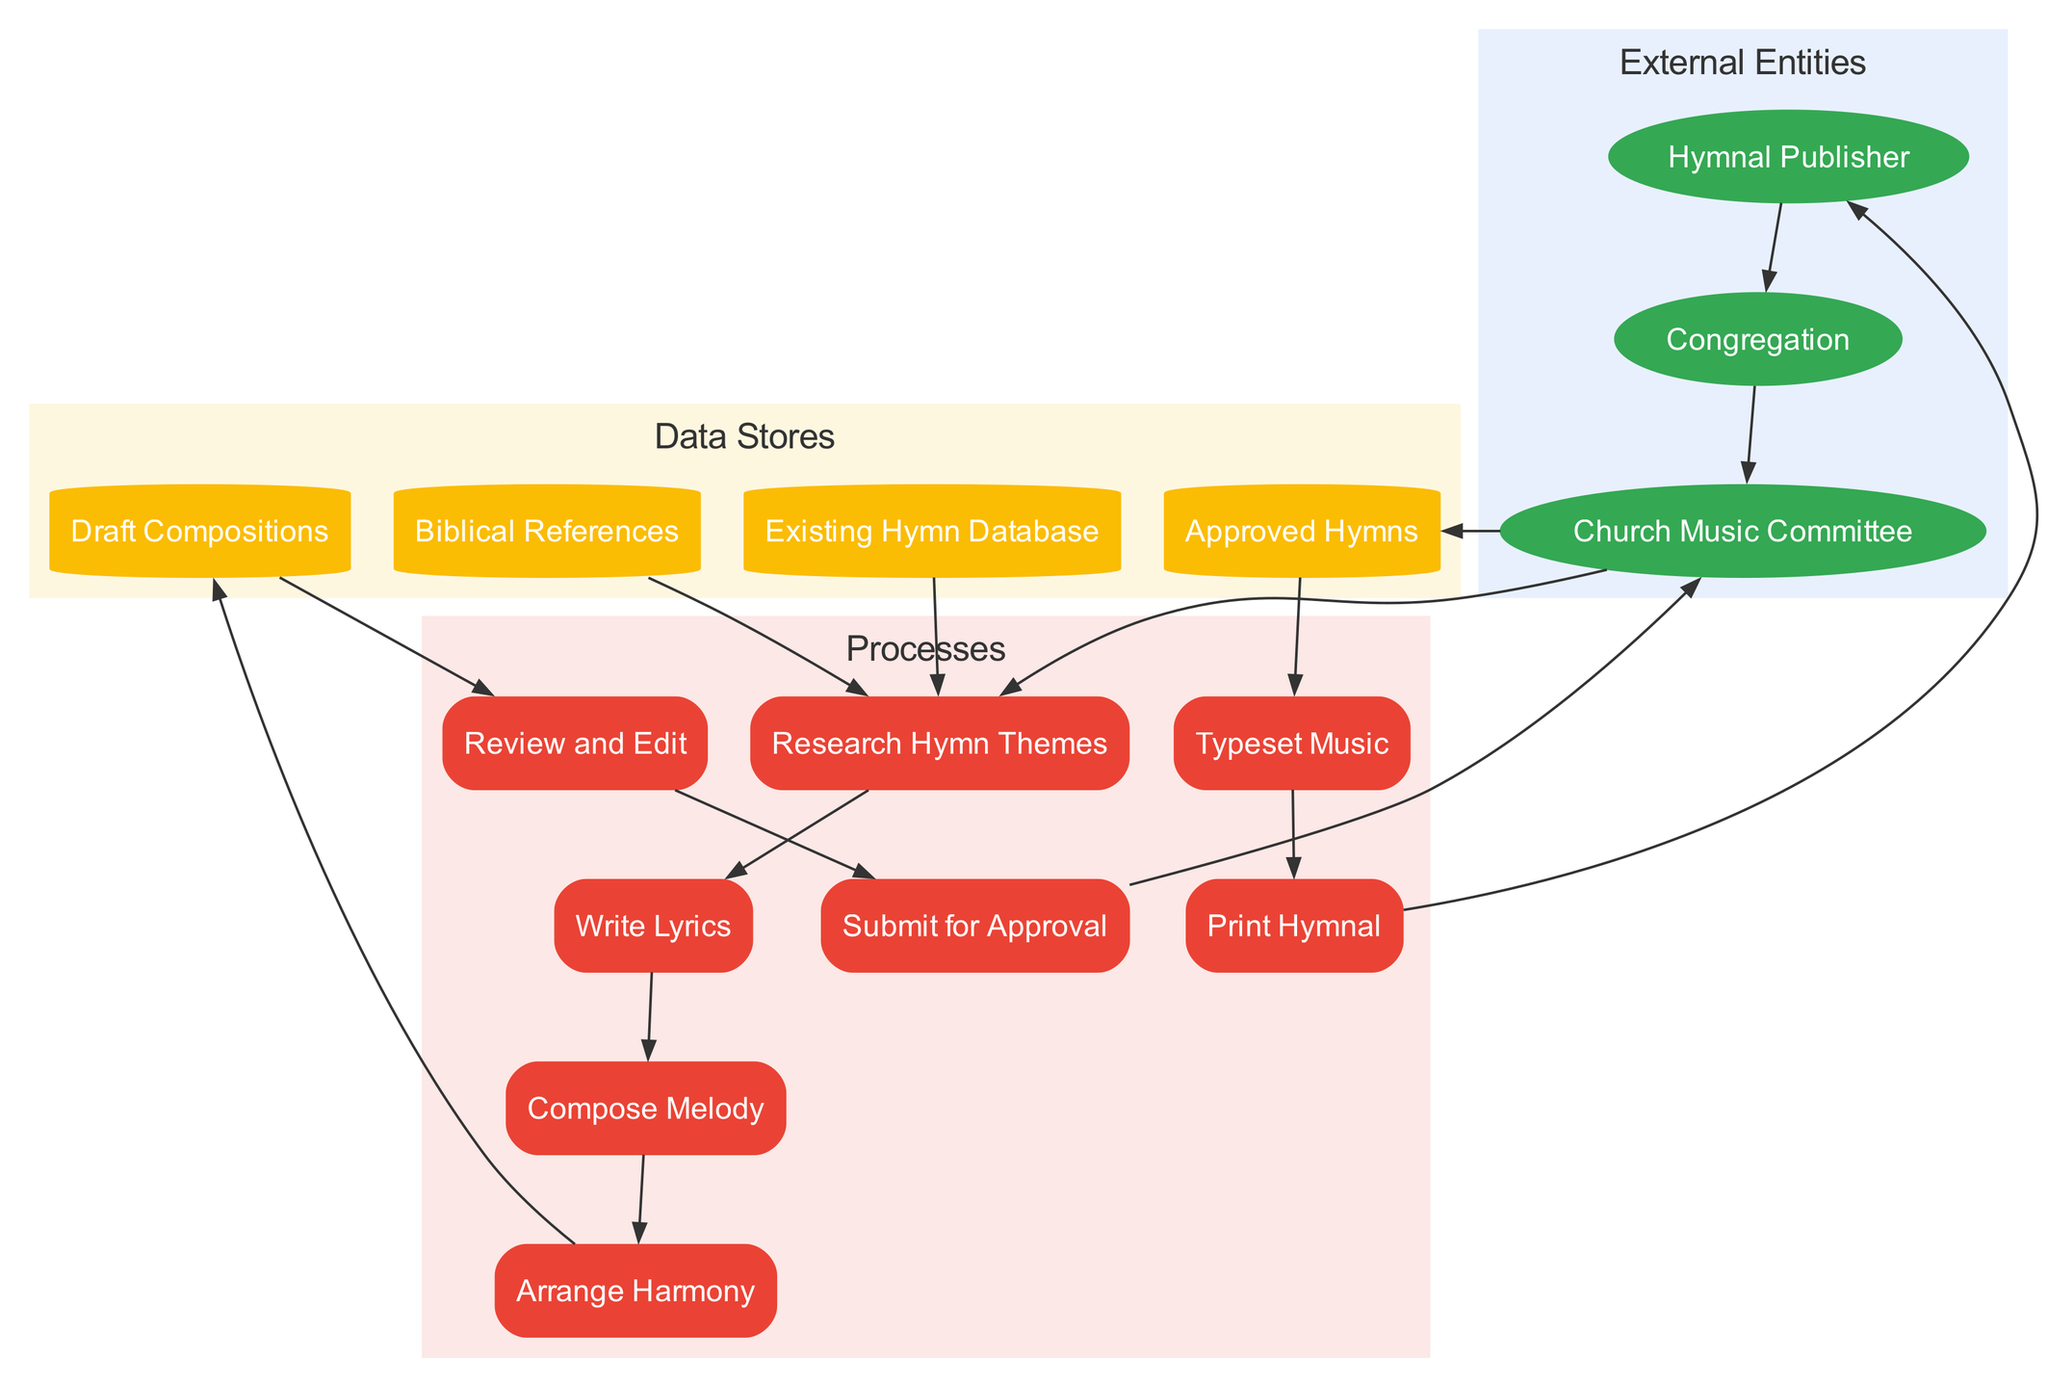What are the external entities in the process? The diagram lists three external entities: Church Music Committee, Hymnal Publisher, and Congregation. These are represented as ellipses in the "External Entities" section of the diagram.
Answer: Church Music Committee, Hymnal Publisher, Congregation How many processes are involved in the hymn composition? By counting the processes in the "Processes" section of the diagram, we find there are eight distinct processes from "Research Hymn Themes" to "Print Hymnal."
Answer: Eight What follows after "Review and Edit"? The diagram shows that "Review and Edit" leads to "Submit for Approval." This indicates the next step in the composition process clearly depicted by the connecting arrow.
Answer: Submit for Approval Which entity provides feedback? The "Church Music Committee" is the entity that provides feedback according to the flow from it to "Research Hymn Themes" as well as feedback looping back from "Congregation."
Answer: Church Music Committee What data store holds the finalized compositions? The "Approved Hymns" data store contains the finalized compositions as indicated by the flow from "Submit for Approval" to "Approved Hymns."
Answer: Approved Hymns After 'Typeset Music', what is the next process? After "Typeset Music," the next process is "Print Hymnal." This can be seen as an arrow leads directly from the former to the latter in the sequence of processes.
Answer: Print Hymnal Which data flow is used to deliver the Hymnals to the Congregation? The data flow "Printed Hymnals" connects "Print Hymnal" to "Congregation," indicating this flow is specifically for delivering printed copies to the congregation.
Answer: Printed Hymnals How many data stores are present in the diagram? There are four data stores in the diagram: Biblical References, Existing Hymn Database, Draft Compositions, and Approved Hymns. This total can be counted from the "Data Stores" section.
Answer: Four 